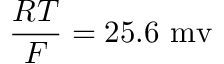<formula> <loc_0><loc_0><loc_500><loc_500>\frac { R T } { F } = 2 5 . 6 m v</formula> 